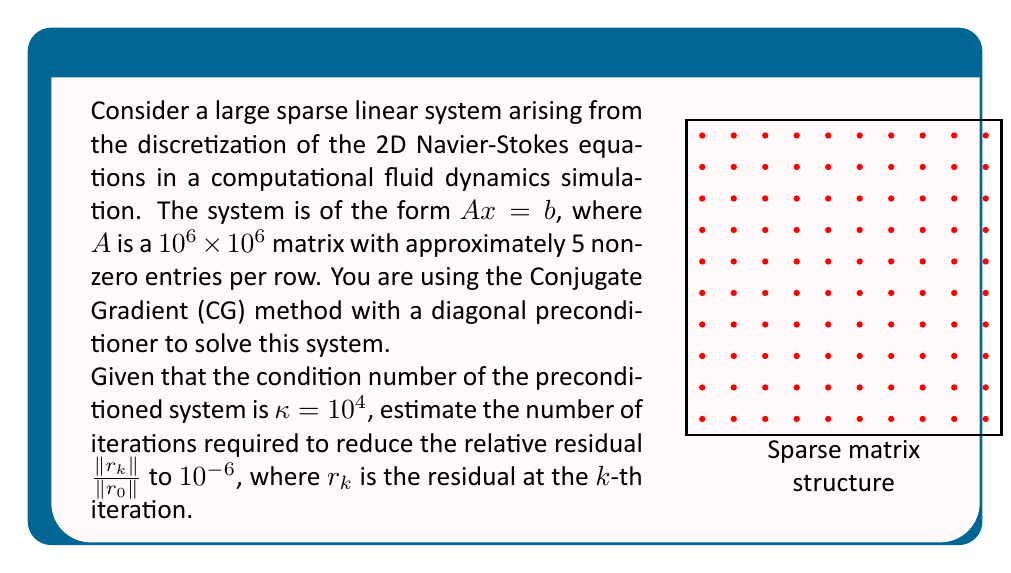Can you answer this question? To solve this problem, we'll use the convergence properties of the Conjugate Gradient method:

1) The convergence rate of CG for a symmetric positive definite system is given by:

   $$\frac{||x_k - x^*||_A}{||x_0 - x^*||_A} \leq 2 \left(\frac{\sqrt{\kappa} - 1}{\sqrt{\kappa} + 1}\right)^k$$

   where $x^*$ is the exact solution, $x_k$ is the approximate solution at iteration $k$, and $\kappa$ is the condition number.

2) We can relate this to the relative residual:

   $$\frac{||r_k||}{||r_0||} \leq \left(\frac{\sqrt{\kappa} - 1}{\sqrt{\kappa} + 1}\right)^k$$

3) Let's denote $\alpha = \frac{\sqrt{\kappa} - 1}{\sqrt{\kappa} + 1}$. We want to find $k$ such that:

   $$\alpha^k \leq 10^{-6}$$

4) Taking logarithms of both sides:

   $$k \log(\alpha) \leq \log(10^{-6})$$

5) Solving for $k$:

   $$k \geq \frac{\log(10^{-6})}{\log(\alpha)}$$

6) Calculate $\alpha$:
   $$\alpha = \frac{\sqrt{10^4} - 1}{\sqrt{10^4} + 1} = \frac{99}{101} \approx 0.9802$$

7) Now we can calculate $k$:

   $$k \geq \frac{\log(10^{-6})}{\log(0.9802)} \approx 1382.6$$

8) Since $k$ must be an integer, we round up to the nearest whole number.
Answer: 1383 iterations 